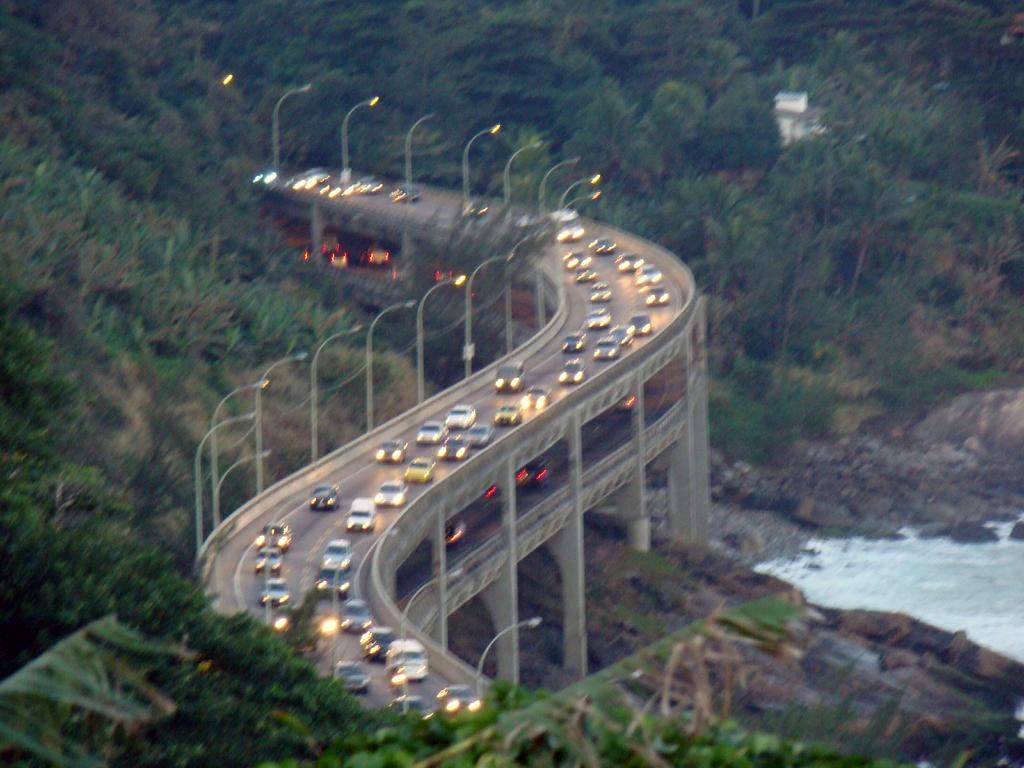What is the primary element in the image? There is water in the image. What structure can be seen crossing over the water? There is a bridge in the image. What types of vehicles are present in the image? There are vehicles in the image. What are the poles with lights used for in the image? The poles with lights are likely used for illumination. What is visible beneath the water in the image? The ground is visible in the image. What objects can be seen on the ground in the image? There are objects on the ground in the image. What type of natural vegetation is present in the image? There are trees in the image. What type of song can be heard playing in the background of the image? There is no sound or music present in the image, so it is not possible to determine what song might be heard. 